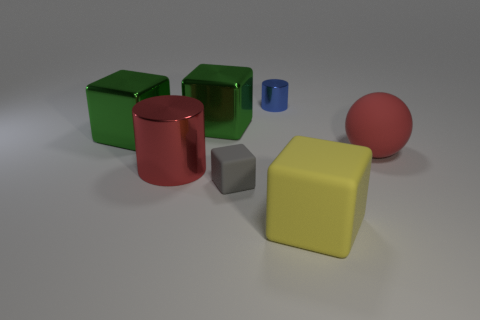Subtract all big yellow cubes. How many cubes are left? 3 Subtract all blue cylinders. How many cylinders are left? 1 Subtract 1 spheres. How many spheres are left? 0 Subtract 1 red spheres. How many objects are left? 6 Subtract all blocks. How many objects are left? 3 Subtract all purple balls. Subtract all purple cylinders. How many balls are left? 1 Subtract all yellow spheres. How many blue blocks are left? 0 Subtract all big red shiny objects. Subtract all big balls. How many objects are left? 5 Add 3 large rubber objects. How many large rubber objects are left? 5 Add 7 gray rubber cubes. How many gray rubber cubes exist? 8 